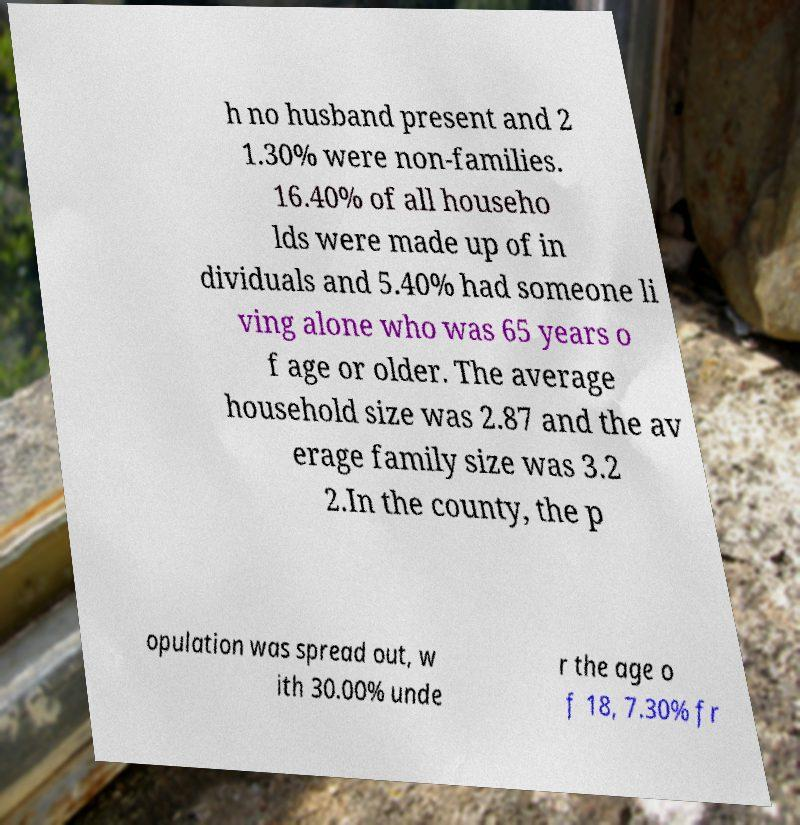Can you read and provide the text displayed in the image?This photo seems to have some interesting text. Can you extract and type it out for me? h no husband present and 2 1.30% were non-families. 16.40% of all househo lds were made up of in dividuals and 5.40% had someone li ving alone who was 65 years o f age or older. The average household size was 2.87 and the av erage family size was 3.2 2.In the county, the p opulation was spread out, w ith 30.00% unde r the age o f 18, 7.30% fr 